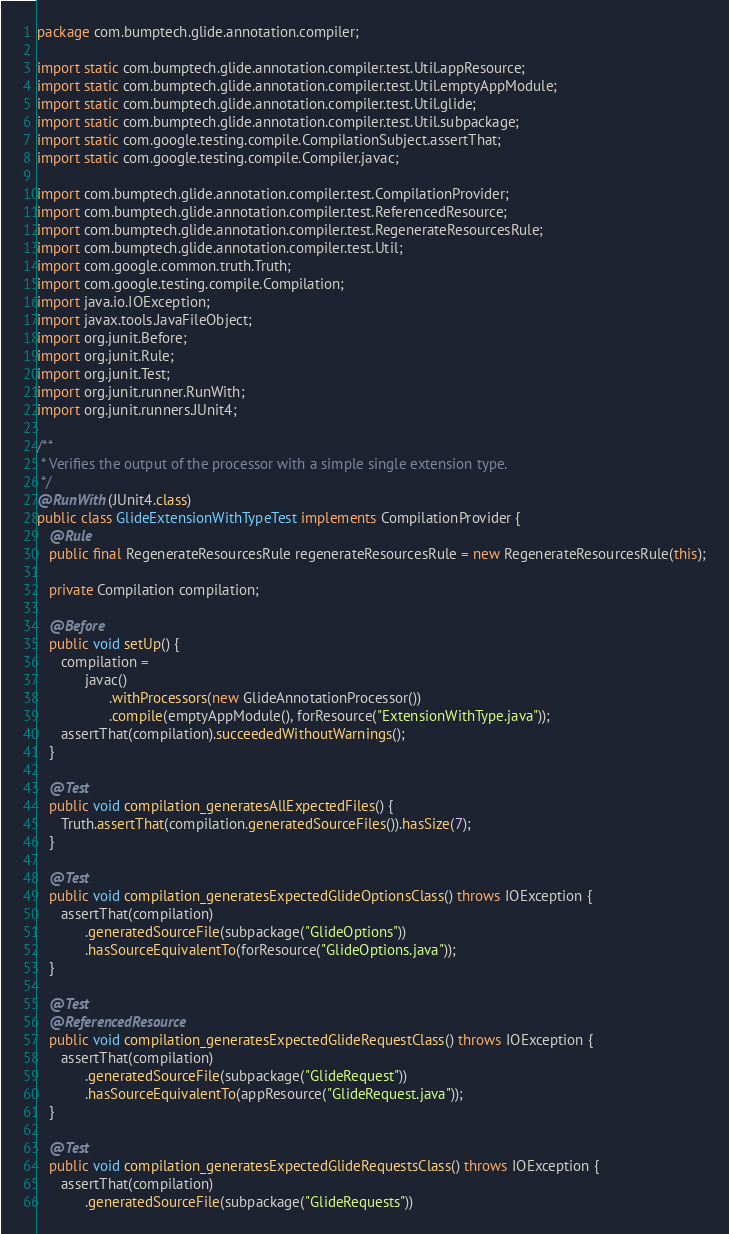Convert code to text. <code><loc_0><loc_0><loc_500><loc_500><_Java_>package com.bumptech.glide.annotation.compiler;

import static com.bumptech.glide.annotation.compiler.test.Util.appResource;
import static com.bumptech.glide.annotation.compiler.test.Util.emptyAppModule;
import static com.bumptech.glide.annotation.compiler.test.Util.glide;
import static com.bumptech.glide.annotation.compiler.test.Util.subpackage;
import static com.google.testing.compile.CompilationSubject.assertThat;
import static com.google.testing.compile.Compiler.javac;

import com.bumptech.glide.annotation.compiler.test.CompilationProvider;
import com.bumptech.glide.annotation.compiler.test.ReferencedResource;
import com.bumptech.glide.annotation.compiler.test.RegenerateResourcesRule;
import com.bumptech.glide.annotation.compiler.test.Util;
import com.google.common.truth.Truth;
import com.google.testing.compile.Compilation;
import java.io.IOException;
import javax.tools.JavaFileObject;
import org.junit.Before;
import org.junit.Rule;
import org.junit.Test;
import org.junit.runner.RunWith;
import org.junit.runners.JUnit4;

/**
 * Verifies the output of the processor with a simple single extension type.
 */
@RunWith(JUnit4.class)
public class GlideExtensionWithTypeTest implements CompilationProvider {
   @Rule
   public final RegenerateResourcesRule regenerateResourcesRule = new RegenerateResourcesRule(this);

   private Compilation compilation;

   @Before
   public void setUp() {
      compilation =
            javac()
                  .withProcessors(new GlideAnnotationProcessor())
                  .compile(emptyAppModule(), forResource("ExtensionWithType.java"));
      assertThat(compilation).succeededWithoutWarnings();
   }

   @Test
   public void compilation_generatesAllExpectedFiles() {
      Truth.assertThat(compilation.generatedSourceFiles()).hasSize(7);
   }

   @Test
   public void compilation_generatesExpectedGlideOptionsClass() throws IOException {
      assertThat(compilation)
            .generatedSourceFile(subpackage("GlideOptions"))
            .hasSourceEquivalentTo(forResource("GlideOptions.java"));
   }

   @Test
   @ReferencedResource
   public void compilation_generatesExpectedGlideRequestClass() throws IOException {
      assertThat(compilation)
            .generatedSourceFile(subpackage("GlideRequest"))
            .hasSourceEquivalentTo(appResource("GlideRequest.java"));
   }

   @Test
   public void compilation_generatesExpectedGlideRequestsClass() throws IOException {
      assertThat(compilation)
            .generatedSourceFile(subpackage("GlideRequests"))</code> 